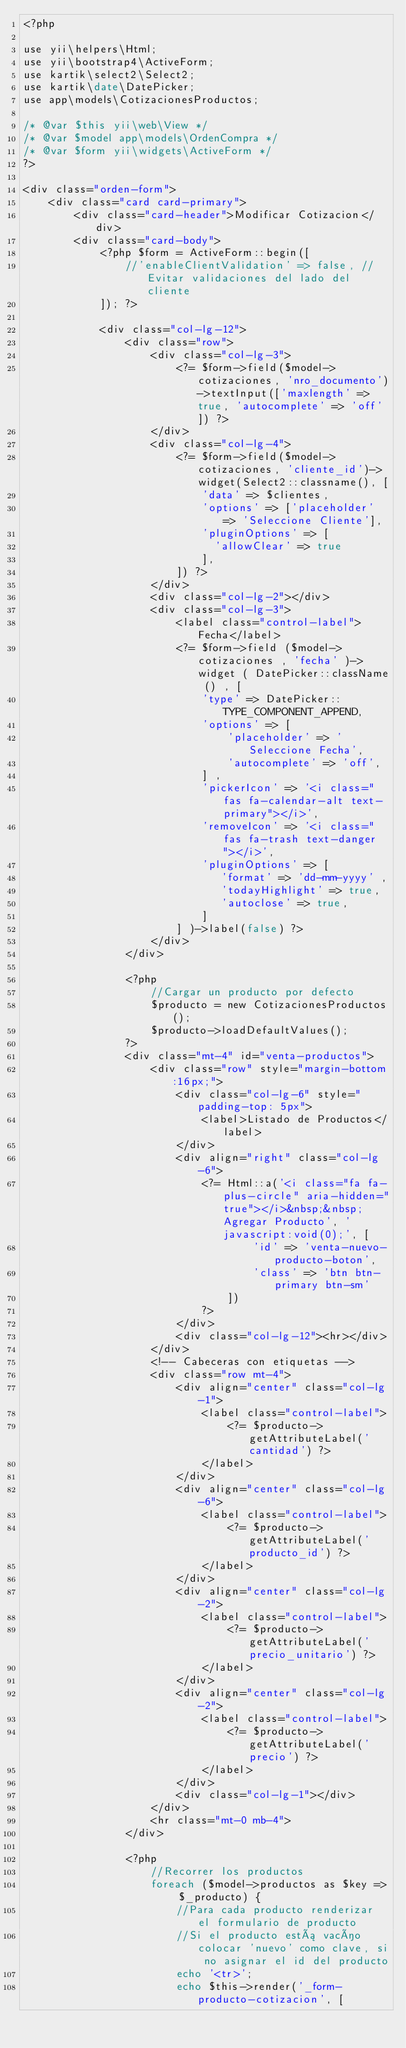<code> <loc_0><loc_0><loc_500><loc_500><_PHP_><?php

use yii\helpers\Html;
use yii\bootstrap4\ActiveForm;
use kartik\select2\Select2;
use kartik\date\DatePicker;
use app\models\CotizacionesProductos;

/* @var $this yii\web\View */
/* @var $model app\models\OrdenCompra */
/* @var $form yii\widgets\ActiveForm */
?>

<div class="orden-form">
    <div class="card card-primary">
        <div class="card-header">Modificar Cotizacion</div>
        <div class="card-body">
            <?php $form = ActiveForm::begin([
                //'enableClientValidation' => false, //Evitar validaciones del lado del cliente
            ]); ?>

            <div class="col-lg-12">
                <div class="row">
                    <div class="col-lg-3">
                        <?= $form->field($model->cotizaciones, 'nro_documento')->textInput(['maxlength' => true, 'autocomplete' => 'off']) ?>
                    </div>
                    <div class="col-lg-4">
                        <?= $form->field($model->cotizaciones, 'cliente_id')->widget(Select2::classname(), [
                            'data' => $clientes,
                            'options' => ['placeholder' => 'Seleccione Cliente'],
                            'pluginOptions' => [
                              'allowClear' => true
                            ],
                        ]) ?>
                    </div>
                    <div class="col-lg-2"></div>
                    <div class="col-lg-3">
                        <label class="control-label">Fecha</label>
                        <?= $form->field ($model->cotizaciones , 'fecha' )->widget ( DatePicker::className () , [
                            'type' => DatePicker::TYPE_COMPONENT_APPEND,
                            'options' => [ 
                                'placeholder' => 'Seleccione Fecha',
                                'autocomplete' => 'off',
                            ] ,
                            'pickerIcon' => '<i class="fas fa-calendar-alt text-primary"></i>',
                            'removeIcon' => '<i class="fas fa-trash text-danger"></i>',
                            'pluginOptions' => [
                               'format' => 'dd-mm-yyyy' ,
                               'todayHighlight' => true,
                               'autoclose' => true,
                            ]
                        ] )->label(false) ?>
                    </div>
                </div>

                <?php
                    //Cargar un producto por defecto
                    $producto = new CotizacionesProductos();
                    $producto->loadDefaultValues();
                ?>
                <div class="mt-4" id="venta-productos">
                    <div class="row" style="margin-bottom:16px;">
                        <div class="col-lg-6" style="padding-top: 5px">
                            <label>Listado de Productos</label>
                        </div>
                        <div align="right" class="col-lg-6">
                            <?= Html::a('<i class="fa fa-plus-circle" aria-hidden="true"></i>&nbsp;&nbsp;Agregar Producto', 'javascript:void(0);', [
                                    'id' => 'venta-nuevo-producto-boton',
                                    'class' => 'btn btn-primary btn-sm'
                                ])
                            ?>
                        </div>
                        <div class="col-lg-12"><hr></div>
                    </div>
                    <!-- Cabeceras con etiquetas -->
                    <div class="row mt-4">
                        <div align="center" class="col-lg-1">
                            <label class="control-label">
                                <?= $producto->getAttributeLabel('cantidad') ?>
                            </label>
                        </div>
                        <div align="center" class="col-lg-6">
                            <label class="control-label">
                                <?= $producto->getAttributeLabel('producto_id') ?>
                            </label>
                        </div>             
                        <div align="center" class="col-lg-2">
                            <label class="control-label">
                                <?= $producto->getAttributeLabel('precio_unitario') ?>
                            </label>
                        </div>
                        <div align="center" class="col-lg-2">
                            <label class="control-label">
                                <?= $producto->getAttributeLabel('precio') ?>
                            </label>
                        </div>            
                        <div class="col-lg-1"></div>
                    </div>
                    <hr class="mt-0 mb-4">
                </div>

                <?php
                    //Recorrer los productos
                    foreach ($model->productos as $key => $_producto) {
                        //Para cada producto renderizar el formulario de producto
                        //Si el producto está vacío colocar 'nuevo' como clave, si no asignar el id del producto
                        echo '<tr>';
                        echo $this->render('_form-producto-cotizacion', [</code> 